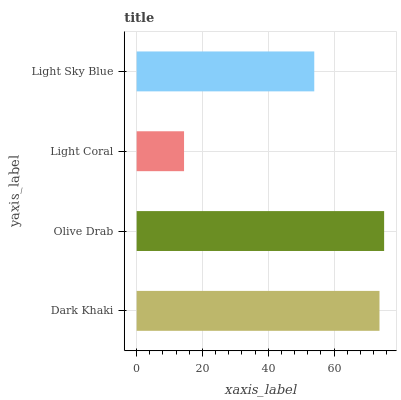Is Light Coral the minimum?
Answer yes or no. Yes. Is Olive Drab the maximum?
Answer yes or no. Yes. Is Olive Drab the minimum?
Answer yes or no. No. Is Light Coral the maximum?
Answer yes or no. No. Is Olive Drab greater than Light Coral?
Answer yes or no. Yes. Is Light Coral less than Olive Drab?
Answer yes or no. Yes. Is Light Coral greater than Olive Drab?
Answer yes or no. No. Is Olive Drab less than Light Coral?
Answer yes or no. No. Is Dark Khaki the high median?
Answer yes or no. Yes. Is Light Sky Blue the low median?
Answer yes or no. Yes. Is Light Coral the high median?
Answer yes or no. No. Is Dark Khaki the low median?
Answer yes or no. No. 